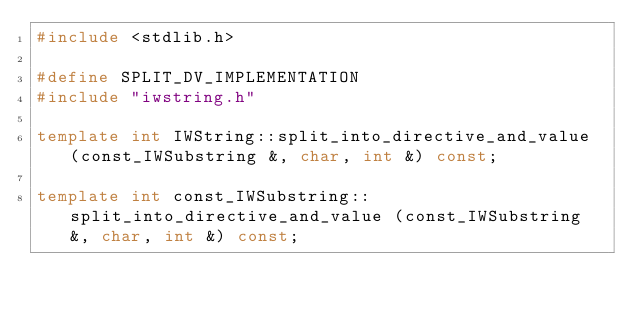<code> <loc_0><loc_0><loc_500><loc_500><_C++_>#include <stdlib.h>

#define SPLIT_DV_IMPLEMENTATION
#include "iwstring.h"

template int IWString::split_into_directive_and_value (const_IWSubstring &, char, int &) const;

template int const_IWSubstring::split_into_directive_and_value (const_IWSubstring &, char, int &) const;
</code> 